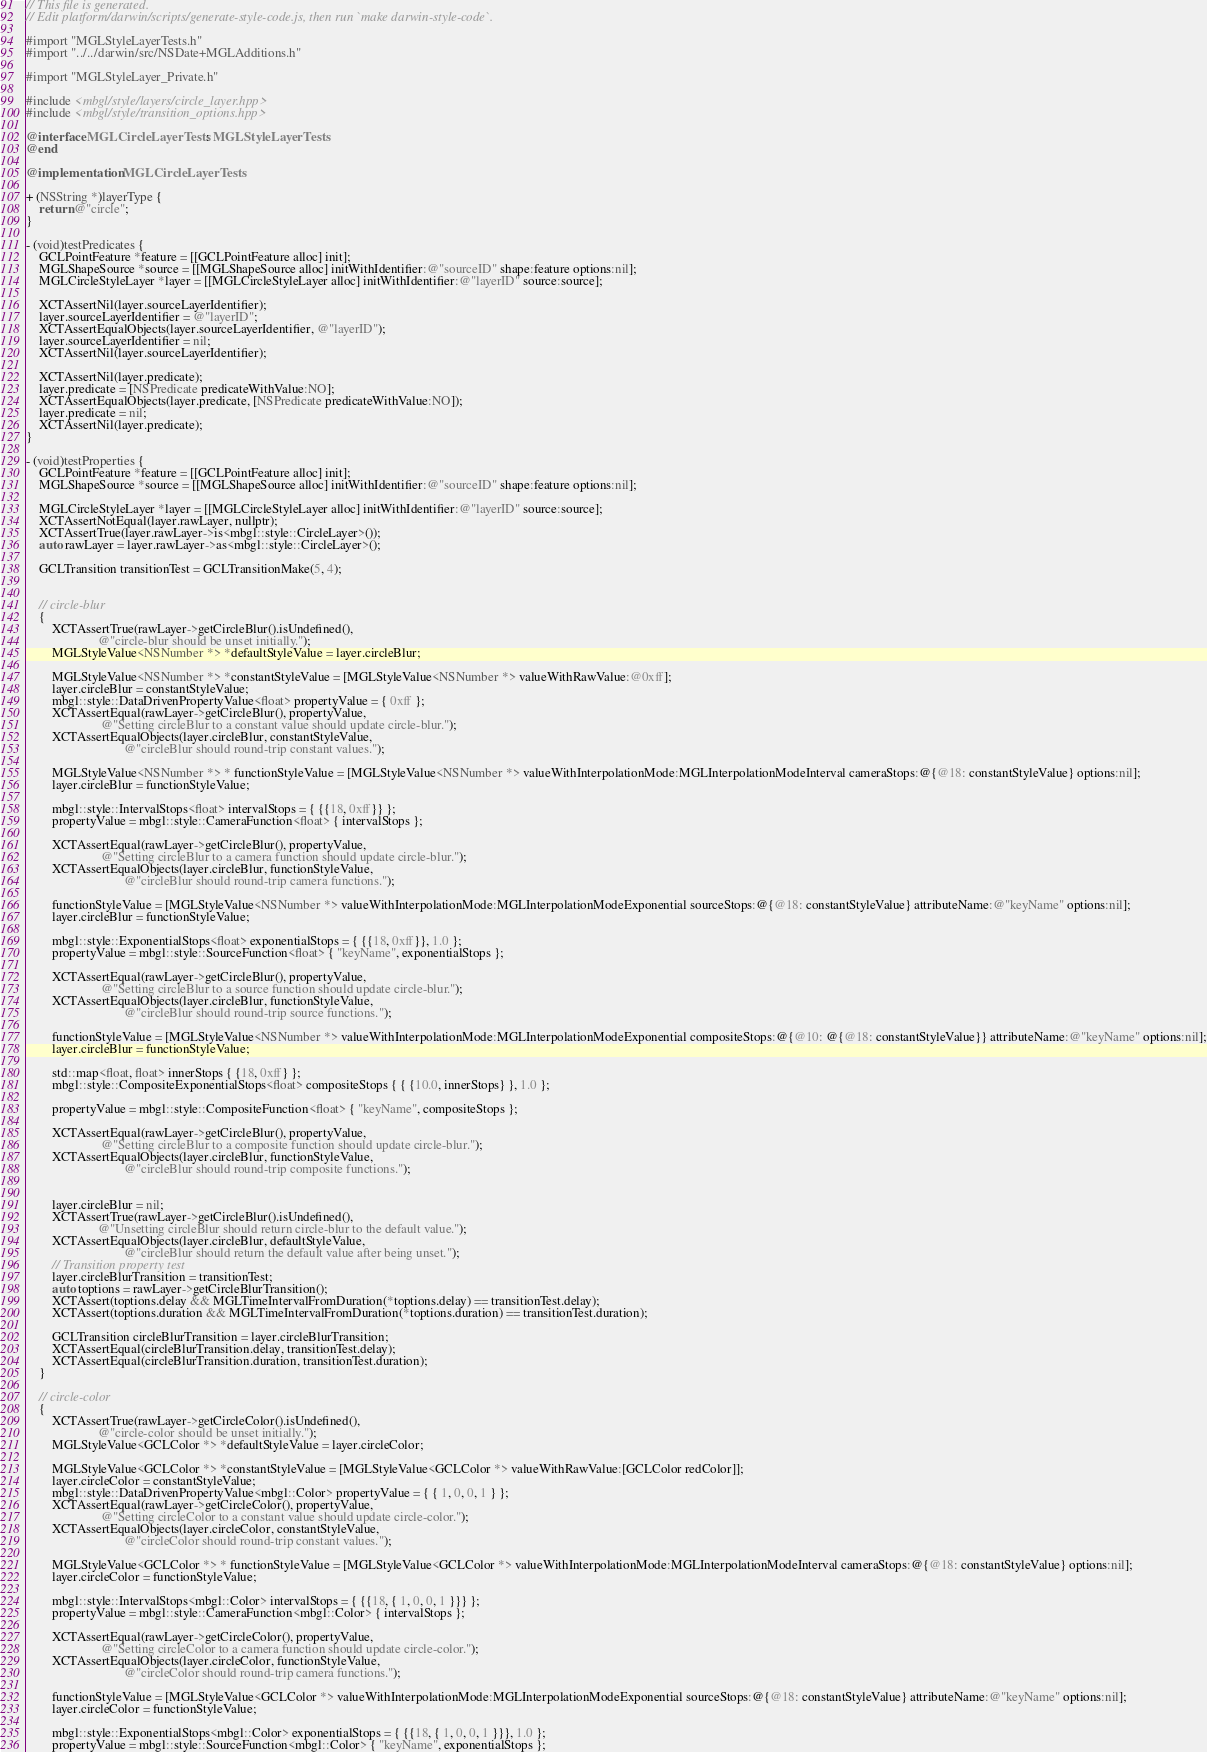Convert code to text. <code><loc_0><loc_0><loc_500><loc_500><_ObjectiveC_>// This file is generated.
// Edit platform/darwin/scripts/generate-style-code.js, then run `make darwin-style-code`.

#import "MGLStyleLayerTests.h"
#import "../../darwin/src/NSDate+MGLAdditions.h"

#import "MGLStyleLayer_Private.h"

#include <mbgl/style/layers/circle_layer.hpp>
#include <mbgl/style/transition_options.hpp>

@interface MGLCircleLayerTests : MGLStyleLayerTests
@end

@implementation MGLCircleLayerTests

+ (NSString *)layerType {
    return @"circle";
}

- (void)testPredicates {
    GCLPointFeature *feature = [[GCLPointFeature alloc] init];
    MGLShapeSource *source = [[MGLShapeSource alloc] initWithIdentifier:@"sourceID" shape:feature options:nil];
    MGLCircleStyleLayer *layer = [[MGLCircleStyleLayer alloc] initWithIdentifier:@"layerID" source:source];

    XCTAssertNil(layer.sourceLayerIdentifier);
    layer.sourceLayerIdentifier = @"layerID";
    XCTAssertEqualObjects(layer.sourceLayerIdentifier, @"layerID");
    layer.sourceLayerIdentifier = nil;
    XCTAssertNil(layer.sourceLayerIdentifier);

    XCTAssertNil(layer.predicate);
    layer.predicate = [NSPredicate predicateWithValue:NO];
    XCTAssertEqualObjects(layer.predicate, [NSPredicate predicateWithValue:NO]);
    layer.predicate = nil;
    XCTAssertNil(layer.predicate);
}

- (void)testProperties {
    GCLPointFeature *feature = [[GCLPointFeature alloc] init];
    MGLShapeSource *source = [[MGLShapeSource alloc] initWithIdentifier:@"sourceID" shape:feature options:nil];

    MGLCircleStyleLayer *layer = [[MGLCircleStyleLayer alloc] initWithIdentifier:@"layerID" source:source];
    XCTAssertNotEqual(layer.rawLayer, nullptr);
    XCTAssertTrue(layer.rawLayer->is<mbgl::style::CircleLayer>());
    auto rawLayer = layer.rawLayer->as<mbgl::style::CircleLayer>();

    GCLTransition transitionTest = GCLTransitionMake(5, 4);


    // circle-blur
    {
        XCTAssertTrue(rawLayer->getCircleBlur().isUndefined(),
                      @"circle-blur should be unset initially.");
        MGLStyleValue<NSNumber *> *defaultStyleValue = layer.circleBlur;

        MGLStyleValue<NSNumber *> *constantStyleValue = [MGLStyleValue<NSNumber *> valueWithRawValue:@0xff];
        layer.circleBlur = constantStyleValue;
        mbgl::style::DataDrivenPropertyValue<float> propertyValue = { 0xff };
        XCTAssertEqual(rawLayer->getCircleBlur(), propertyValue,
                       @"Setting circleBlur to a constant value should update circle-blur.");
        XCTAssertEqualObjects(layer.circleBlur, constantStyleValue,
                              @"circleBlur should round-trip constant values.");

        MGLStyleValue<NSNumber *> * functionStyleValue = [MGLStyleValue<NSNumber *> valueWithInterpolationMode:MGLInterpolationModeInterval cameraStops:@{@18: constantStyleValue} options:nil];
        layer.circleBlur = functionStyleValue;

        mbgl::style::IntervalStops<float> intervalStops = { {{18, 0xff}} };
        propertyValue = mbgl::style::CameraFunction<float> { intervalStops };
        
        XCTAssertEqual(rawLayer->getCircleBlur(), propertyValue,
                       @"Setting circleBlur to a camera function should update circle-blur.");
        XCTAssertEqualObjects(layer.circleBlur, functionStyleValue,
                              @"circleBlur should round-trip camera functions.");

        functionStyleValue = [MGLStyleValue<NSNumber *> valueWithInterpolationMode:MGLInterpolationModeExponential sourceStops:@{@18: constantStyleValue} attributeName:@"keyName" options:nil];
        layer.circleBlur = functionStyleValue;

        mbgl::style::ExponentialStops<float> exponentialStops = { {{18, 0xff}}, 1.0 };
        propertyValue = mbgl::style::SourceFunction<float> { "keyName", exponentialStops };

        XCTAssertEqual(rawLayer->getCircleBlur(), propertyValue,
                       @"Setting circleBlur to a source function should update circle-blur.");
        XCTAssertEqualObjects(layer.circleBlur, functionStyleValue,
                              @"circleBlur should round-trip source functions.");

        functionStyleValue = [MGLStyleValue<NSNumber *> valueWithInterpolationMode:MGLInterpolationModeExponential compositeStops:@{@10: @{@18: constantStyleValue}} attributeName:@"keyName" options:nil];
        layer.circleBlur = functionStyleValue;

        std::map<float, float> innerStops { {18, 0xff} };
        mbgl::style::CompositeExponentialStops<float> compositeStops { { {10.0, innerStops} }, 1.0 };

        propertyValue = mbgl::style::CompositeFunction<float> { "keyName", compositeStops };

        XCTAssertEqual(rawLayer->getCircleBlur(), propertyValue,
                       @"Setting circleBlur to a composite function should update circle-blur.");
        XCTAssertEqualObjects(layer.circleBlur, functionStyleValue,
                              @"circleBlur should round-trip composite functions.");                                                                                                          
                              

        layer.circleBlur = nil;
        XCTAssertTrue(rawLayer->getCircleBlur().isUndefined(),
                      @"Unsetting circleBlur should return circle-blur to the default value.");
        XCTAssertEqualObjects(layer.circleBlur, defaultStyleValue,
                              @"circleBlur should return the default value after being unset.");
        // Transition property test
        layer.circleBlurTransition = transitionTest;
        auto toptions = rawLayer->getCircleBlurTransition();
        XCTAssert(toptions.delay && MGLTimeIntervalFromDuration(*toptions.delay) == transitionTest.delay);
        XCTAssert(toptions.duration && MGLTimeIntervalFromDuration(*toptions.duration) == transitionTest.duration);

        GCLTransition circleBlurTransition = layer.circleBlurTransition;
        XCTAssertEqual(circleBlurTransition.delay, transitionTest.delay);
        XCTAssertEqual(circleBlurTransition.duration, transitionTest.duration);
    }

    // circle-color
    {
        XCTAssertTrue(rawLayer->getCircleColor().isUndefined(),
                      @"circle-color should be unset initially.");
        MGLStyleValue<GCLColor *> *defaultStyleValue = layer.circleColor;

        MGLStyleValue<GCLColor *> *constantStyleValue = [MGLStyleValue<GCLColor *> valueWithRawValue:[GCLColor redColor]];
        layer.circleColor = constantStyleValue;
        mbgl::style::DataDrivenPropertyValue<mbgl::Color> propertyValue = { { 1, 0, 0, 1 } };
        XCTAssertEqual(rawLayer->getCircleColor(), propertyValue,
                       @"Setting circleColor to a constant value should update circle-color.");
        XCTAssertEqualObjects(layer.circleColor, constantStyleValue,
                              @"circleColor should round-trip constant values.");

        MGLStyleValue<GCLColor *> * functionStyleValue = [MGLStyleValue<GCLColor *> valueWithInterpolationMode:MGLInterpolationModeInterval cameraStops:@{@18: constantStyleValue} options:nil];
        layer.circleColor = functionStyleValue;

        mbgl::style::IntervalStops<mbgl::Color> intervalStops = { {{18, { 1, 0, 0, 1 }}} };
        propertyValue = mbgl::style::CameraFunction<mbgl::Color> { intervalStops };
        
        XCTAssertEqual(rawLayer->getCircleColor(), propertyValue,
                       @"Setting circleColor to a camera function should update circle-color.");
        XCTAssertEqualObjects(layer.circleColor, functionStyleValue,
                              @"circleColor should round-trip camera functions.");

        functionStyleValue = [MGLStyleValue<GCLColor *> valueWithInterpolationMode:MGLInterpolationModeExponential sourceStops:@{@18: constantStyleValue} attributeName:@"keyName" options:nil];
        layer.circleColor = functionStyleValue;

        mbgl::style::ExponentialStops<mbgl::Color> exponentialStops = { {{18, { 1, 0, 0, 1 }}}, 1.0 };
        propertyValue = mbgl::style::SourceFunction<mbgl::Color> { "keyName", exponentialStops };
</code> 